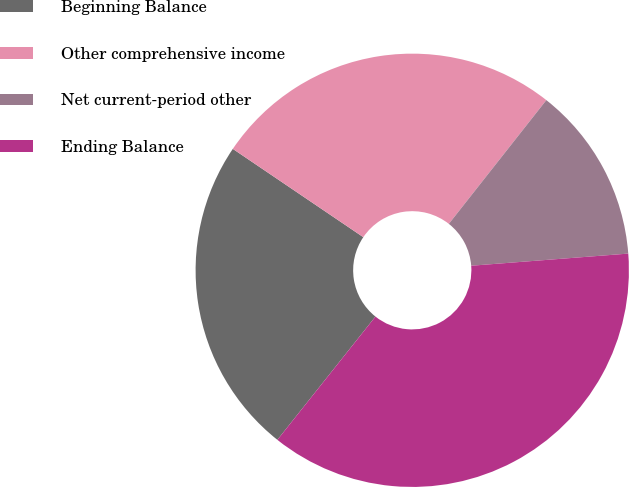Convert chart to OTSL. <chart><loc_0><loc_0><loc_500><loc_500><pie_chart><fcel>Beginning Balance<fcel>Other comprehensive income<fcel>Net current-period other<fcel>Ending Balance<nl><fcel>23.77%<fcel>26.15%<fcel>13.15%<fcel>36.92%<nl></chart> 